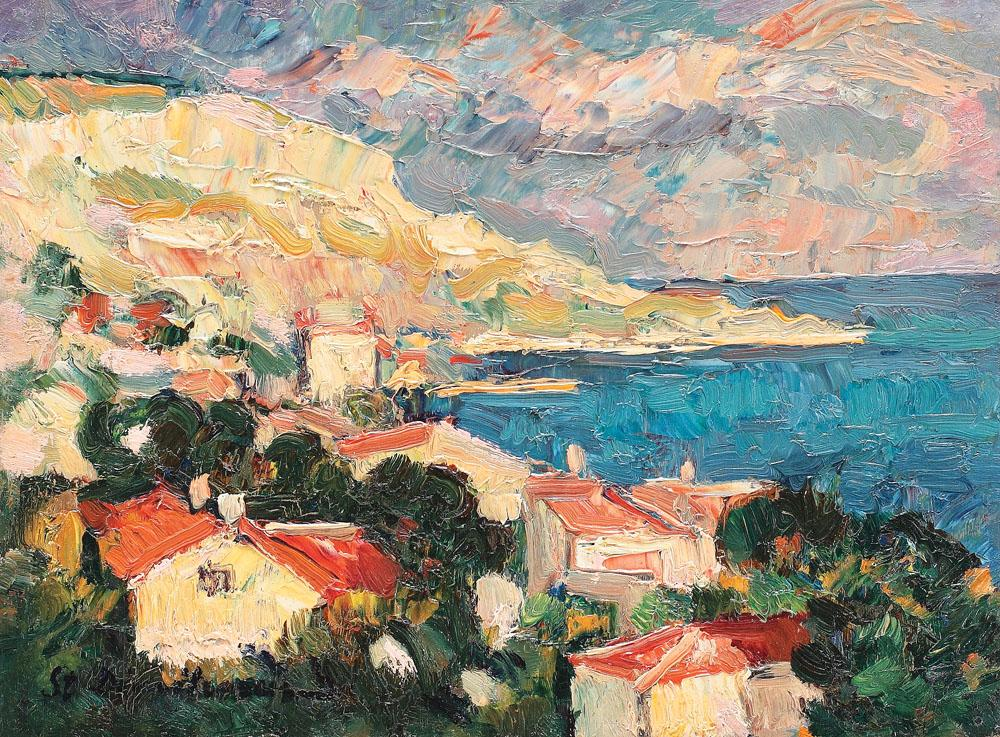Can you describe the mood created by the color palette in this painting? The color palette in this painting creates a mood of serene vibrancy. The usage of lively blues and calm greens evoke a sense of tranquility, indicative of the coastal setting. Meanwhile, the bold reds of the roofs and the gentle transitions to soft pinks and oranges in the sky suggest an environment filled with warm, ambient light, likely captured during a sunset. This combination sets a mood that is both peaceful and invigorating, encapsulating the essence of a picturesque, idyllic coastal village. 